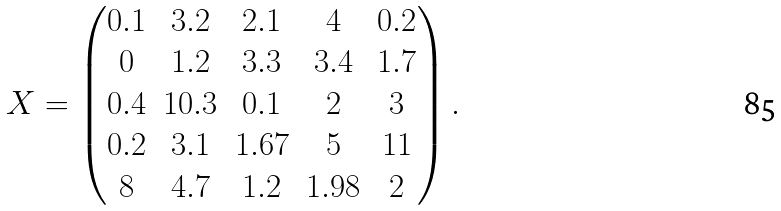<formula> <loc_0><loc_0><loc_500><loc_500>X = \begin{pmatrix} 0 . 1 & 3 . 2 & 2 . 1 & 4 & 0 . 2 \\ 0 & 1 . 2 & 3 . 3 & 3 . 4 & 1 . 7 \\ 0 . 4 & 1 0 . 3 & 0 . 1 & 2 & 3 \\ 0 . 2 & 3 . 1 & 1 . 6 7 & 5 & 1 1 \\ 8 & 4 . 7 & 1 . 2 & 1 . 9 8 & 2 \end{pmatrix} .</formula> 